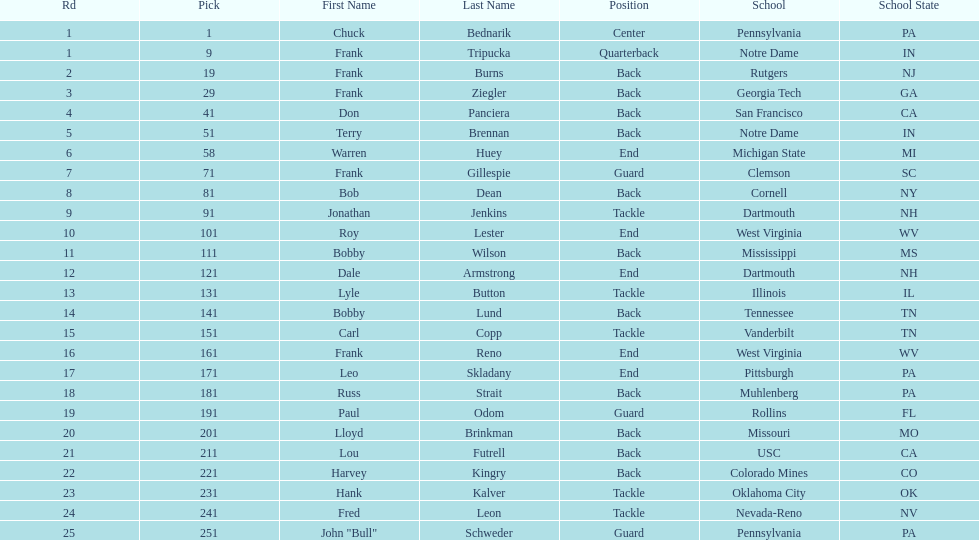How many draft picks were between frank tripucka and dale armstrong? 10. 